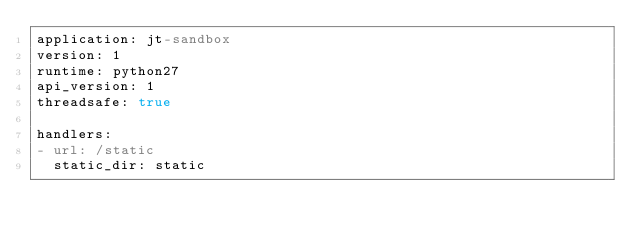Convert code to text. <code><loc_0><loc_0><loc_500><loc_500><_YAML_>application: jt-sandbox
version: 1
runtime: python27
api_version: 1
threadsafe: true

handlers:
- url: /static
  static_dir: static
</code> 